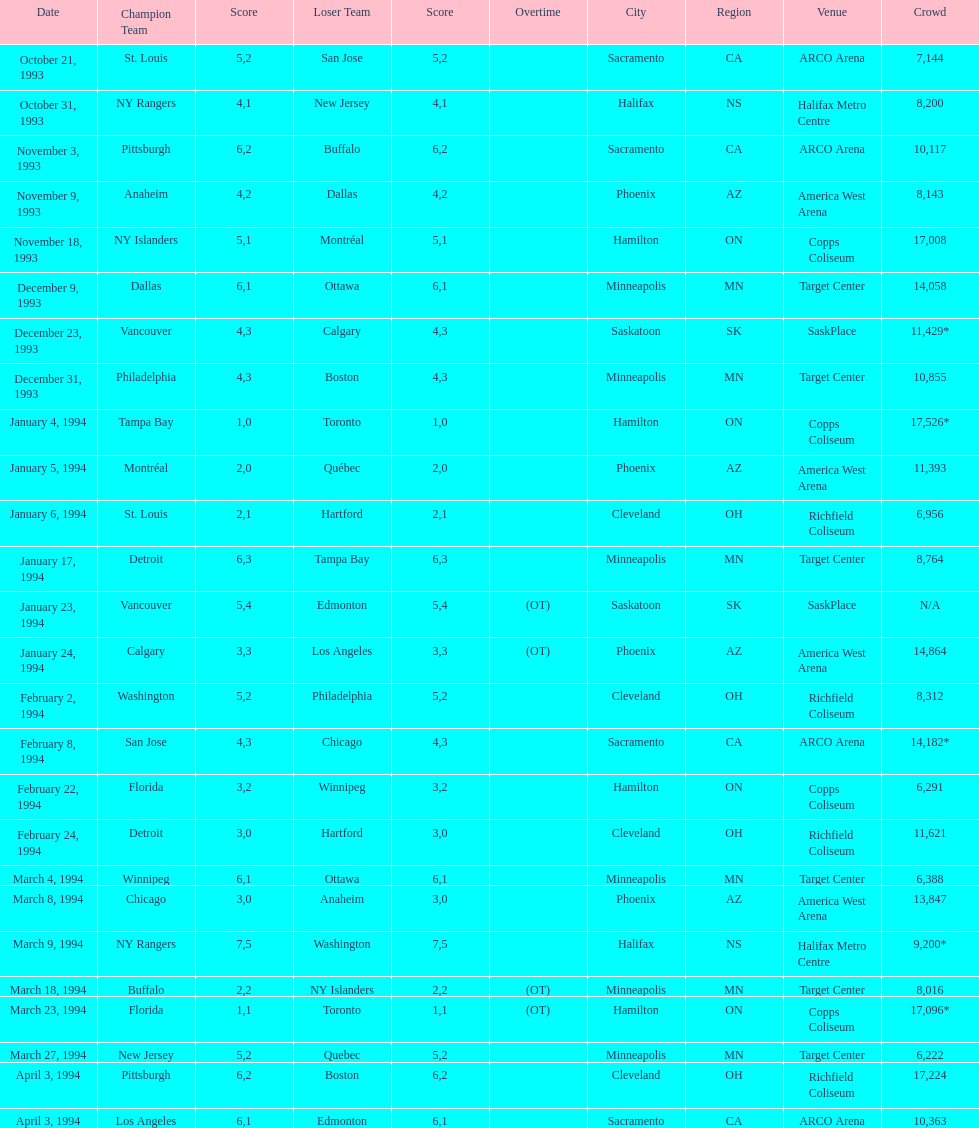The game on which date had the most attendance? January 4, 1994. 